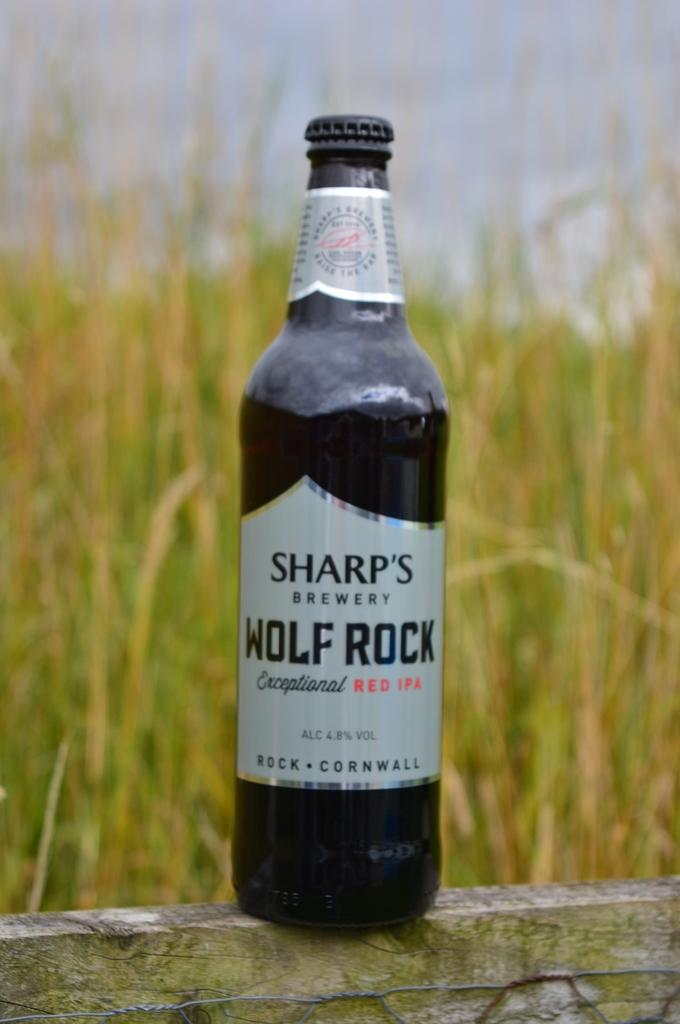Provide a one-sentence caption for the provided image. A bottle of Sharp's Wolf Rock beer with a field in the background. 